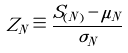Convert formula to latex. <formula><loc_0><loc_0><loc_500><loc_500>Z _ { N } \equiv \frac { S _ { ( N ) } - \mu _ { N } } { \sigma _ { N } }</formula> 